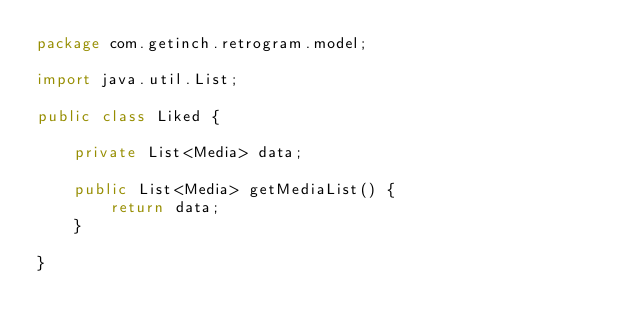<code> <loc_0><loc_0><loc_500><loc_500><_Java_>package com.getinch.retrogram.model;

import java.util.List;

public class Liked {

    private List<Media> data;

    public List<Media> getMediaList() {
        return data;
    }

}
</code> 